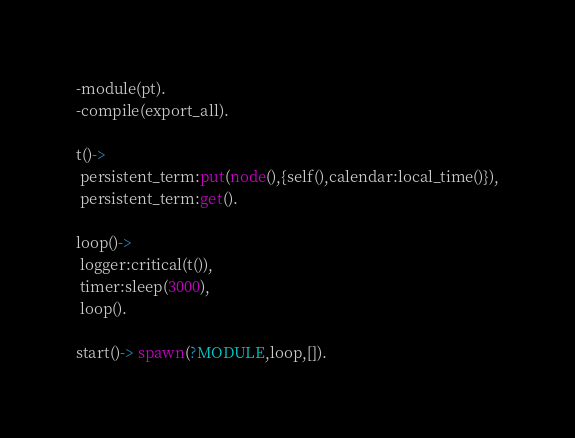Convert code to text. <code><loc_0><loc_0><loc_500><loc_500><_Erlang_>-module(pt).
-compile(export_all).

t()->
 persistent_term:put(node(),{self(),calendar:local_time()}),
 persistent_term:get().

loop()->
 logger:critical(t()),
 timer:sleep(3000),
 loop().

start()-> spawn(?MODULE,loop,[]). </code> 